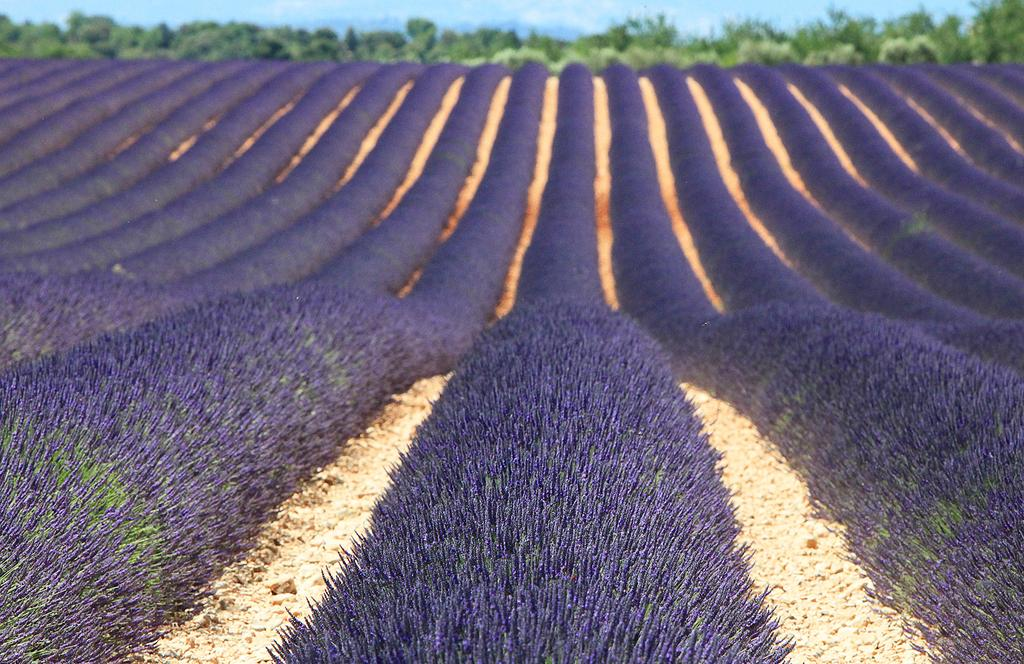What type of plants can be seen in the image? There are plants with flowers in the image. What can be seen in the background of the image? There are trees and the sky visible in the background of the image. What is the condition of the sky in the image? Clouds are present in the sky in the image. How many toothbrushes can be seen in the image? There are no toothbrushes present in the image. What type of lizards can be seen in the image? There are no lizards present in the image. 